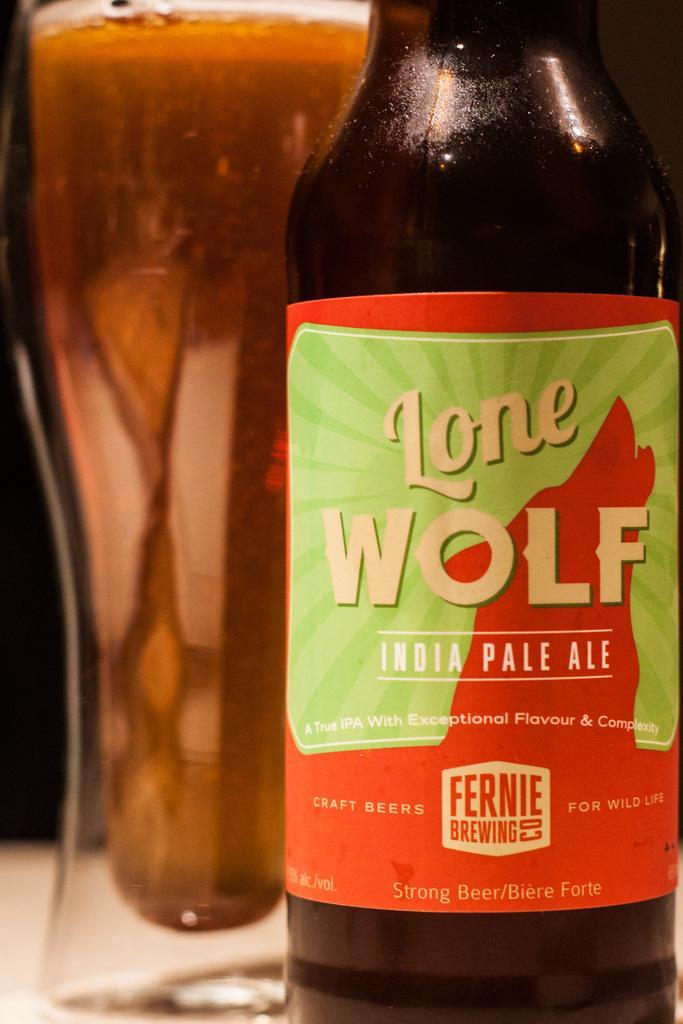Describe this image in one or two sentences. Here I can see a bottle on which a paper is attached. On this paper, I can see some text. On the left side there is a glass which consists of drink. 